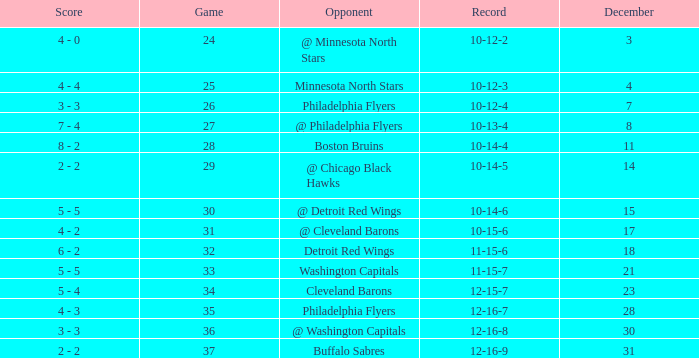What is the lowest December, when Score is "4 - 4"? 4.0. 